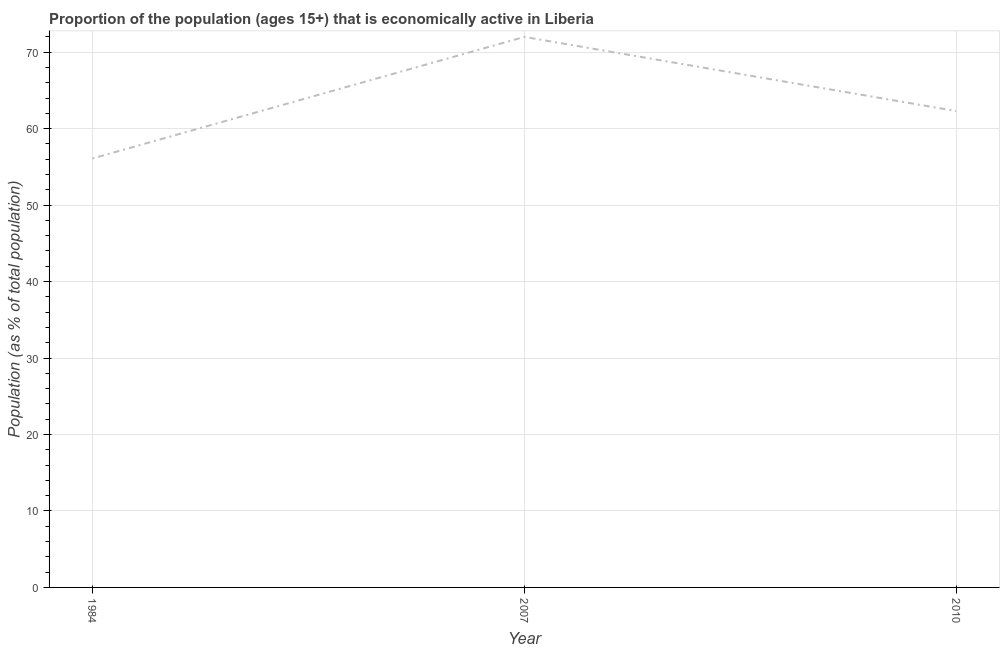What is the percentage of economically active population in 2007?
Give a very brief answer. 72. Across all years, what is the maximum percentage of economically active population?
Provide a succinct answer. 72. Across all years, what is the minimum percentage of economically active population?
Your answer should be compact. 56.1. In which year was the percentage of economically active population maximum?
Keep it short and to the point. 2007. In which year was the percentage of economically active population minimum?
Offer a terse response. 1984. What is the sum of the percentage of economically active population?
Offer a very short reply. 190.4. What is the difference between the percentage of economically active population in 1984 and 2007?
Provide a succinct answer. -15.9. What is the average percentage of economically active population per year?
Provide a short and direct response. 63.47. What is the median percentage of economically active population?
Your answer should be very brief. 62.3. In how many years, is the percentage of economically active population greater than 62 %?
Make the answer very short. 2. Do a majority of the years between 1984 and 2007 (inclusive) have percentage of economically active population greater than 66 %?
Your response must be concise. No. What is the ratio of the percentage of economically active population in 2007 to that in 2010?
Offer a terse response. 1.16. Is the percentage of economically active population in 1984 less than that in 2010?
Provide a short and direct response. Yes. Is the difference between the percentage of economically active population in 2007 and 2010 greater than the difference between any two years?
Keep it short and to the point. No. What is the difference between the highest and the second highest percentage of economically active population?
Ensure brevity in your answer.  9.7. What is the difference between the highest and the lowest percentage of economically active population?
Offer a terse response. 15.9. In how many years, is the percentage of economically active population greater than the average percentage of economically active population taken over all years?
Ensure brevity in your answer.  1. What is the difference between two consecutive major ticks on the Y-axis?
Your answer should be compact. 10. Does the graph contain any zero values?
Offer a terse response. No. What is the title of the graph?
Provide a short and direct response. Proportion of the population (ages 15+) that is economically active in Liberia. What is the label or title of the X-axis?
Ensure brevity in your answer.  Year. What is the label or title of the Y-axis?
Offer a very short reply. Population (as % of total population). What is the Population (as % of total population) of 1984?
Offer a terse response. 56.1. What is the Population (as % of total population) of 2007?
Offer a very short reply. 72. What is the Population (as % of total population) of 2010?
Make the answer very short. 62.3. What is the difference between the Population (as % of total population) in 1984 and 2007?
Your answer should be very brief. -15.9. What is the difference between the Population (as % of total population) in 1984 and 2010?
Your response must be concise. -6.2. What is the difference between the Population (as % of total population) in 2007 and 2010?
Provide a short and direct response. 9.7. What is the ratio of the Population (as % of total population) in 1984 to that in 2007?
Provide a succinct answer. 0.78. What is the ratio of the Population (as % of total population) in 1984 to that in 2010?
Offer a terse response. 0.9. What is the ratio of the Population (as % of total population) in 2007 to that in 2010?
Make the answer very short. 1.16. 